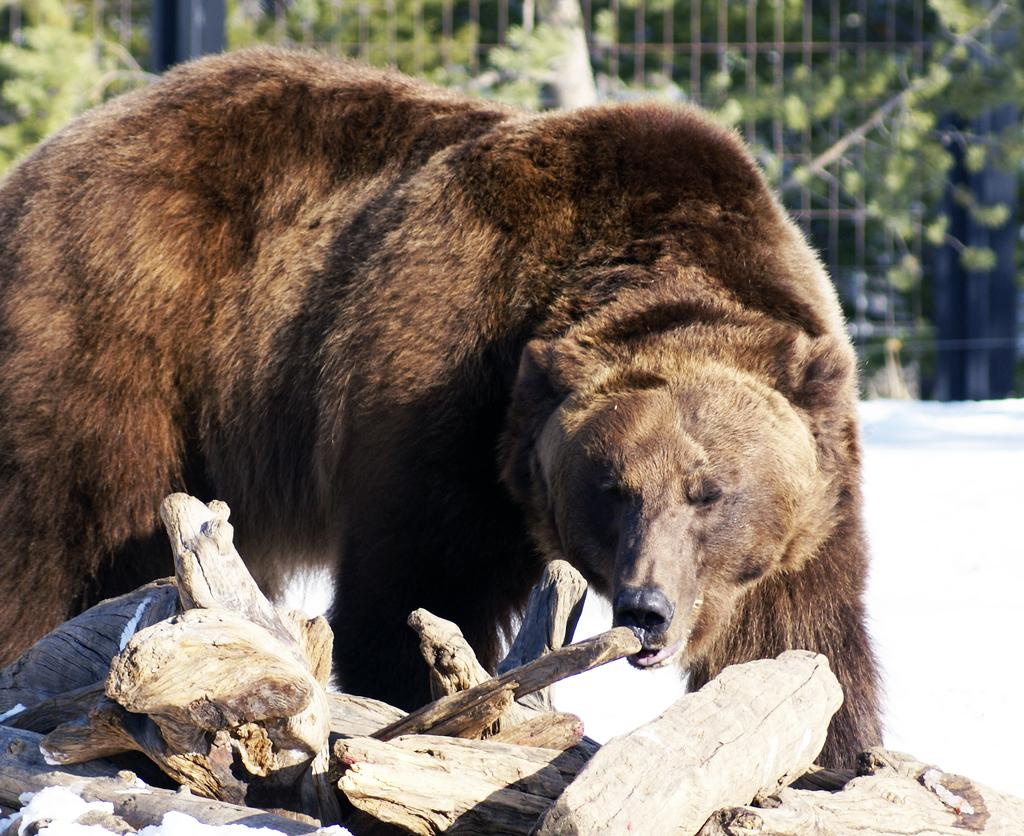What type of animal is in the image? There is a brown bear in the image. What is located at the bottom of the image? There are logs at the bottom of the image. What can be seen in the background of the image? There is a fence and trees in the background of the image. What type of window can be seen in the image? There is no window present in the image. How does the bear express anger in the image? The bear's emotions cannot be determined from the image, as it is a still photograph. 